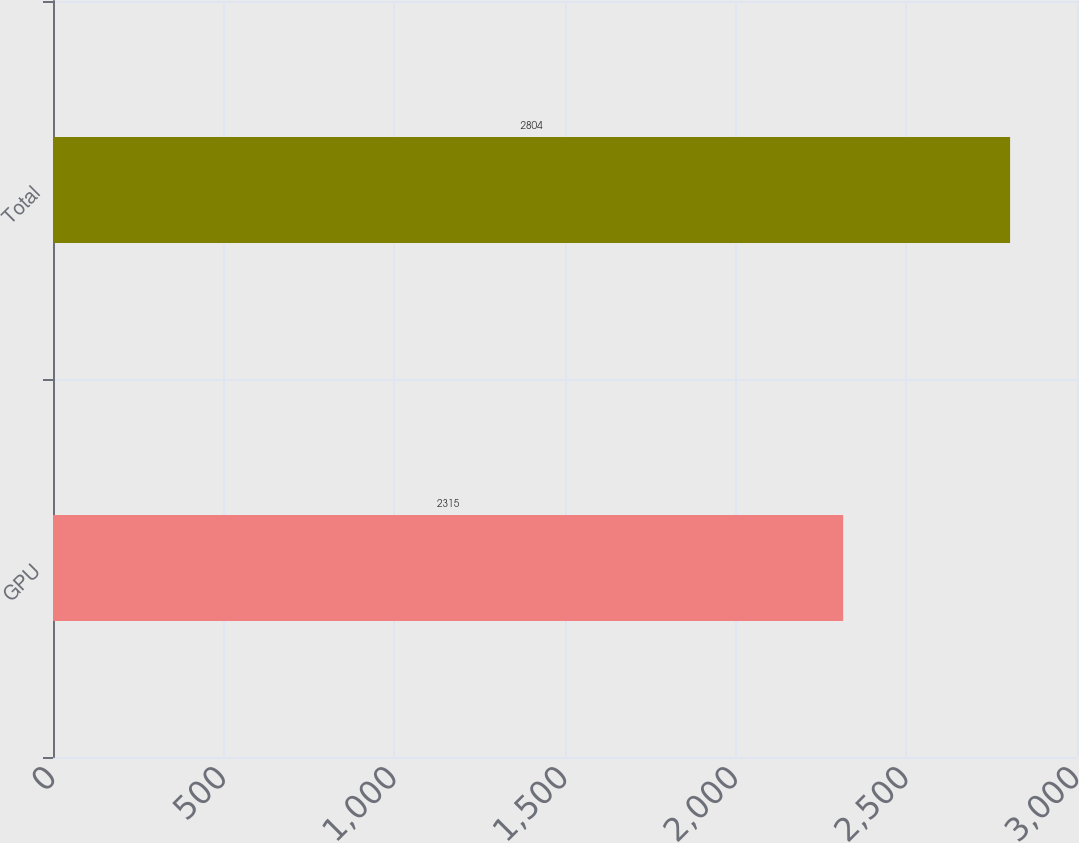Convert chart. <chart><loc_0><loc_0><loc_500><loc_500><bar_chart><fcel>GPU<fcel>Total<nl><fcel>2315<fcel>2804<nl></chart> 